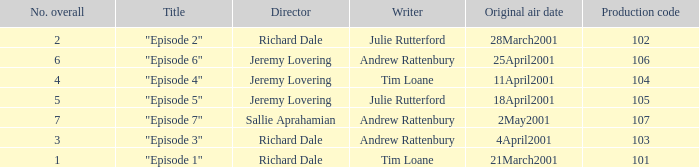When did the episode first air that had a production code of 102? 28March2001. 